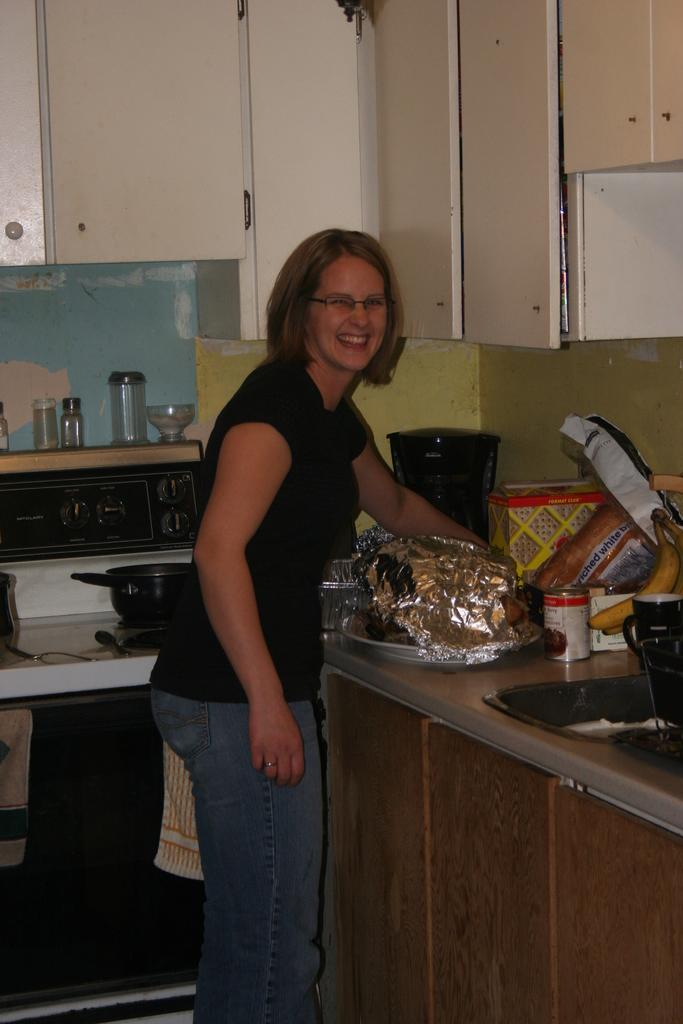<image>
Give a short and clear explanation of the subsequent image. A woman is smiling in the kitchen near a loaf of enriched white bread. 